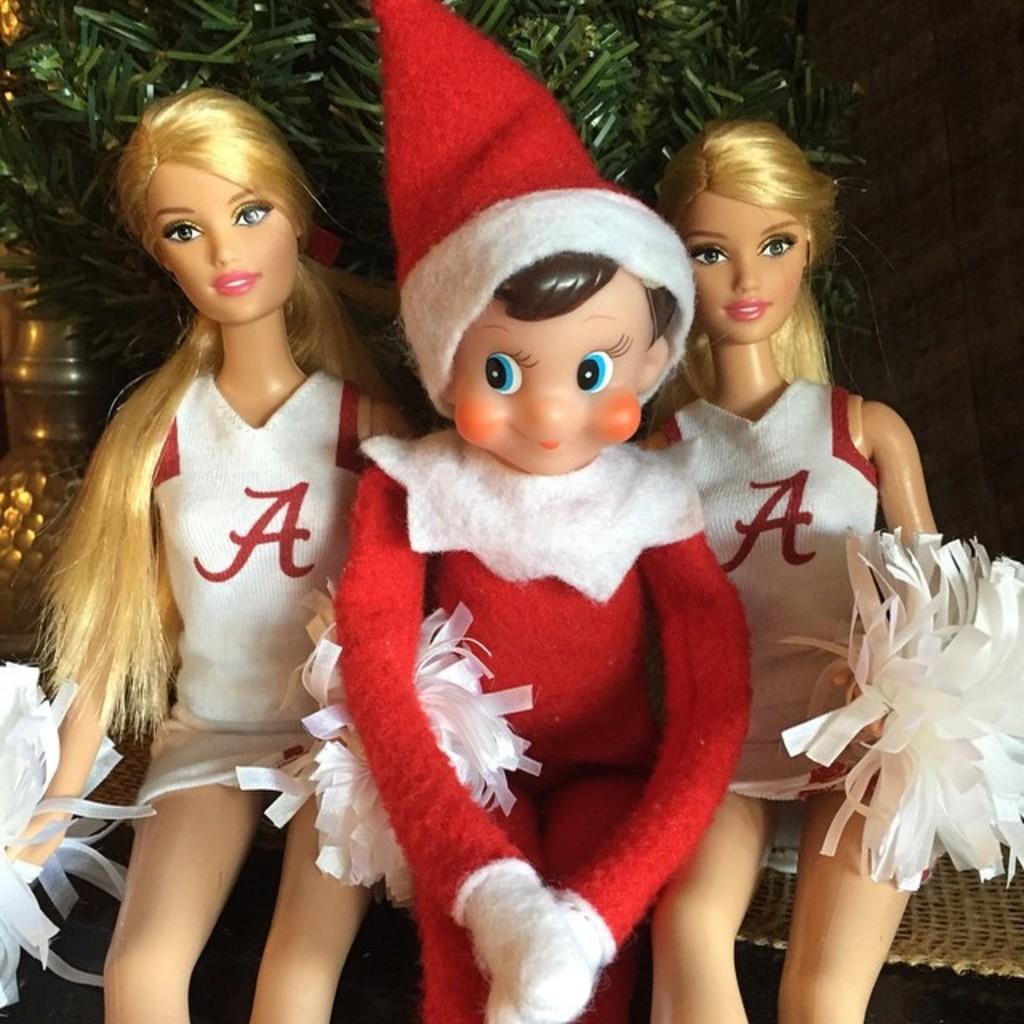How would you summarize this image in a sentence or two? In this image, we can see dolls and ribbons. In the background, we can see green color object and a few things. 